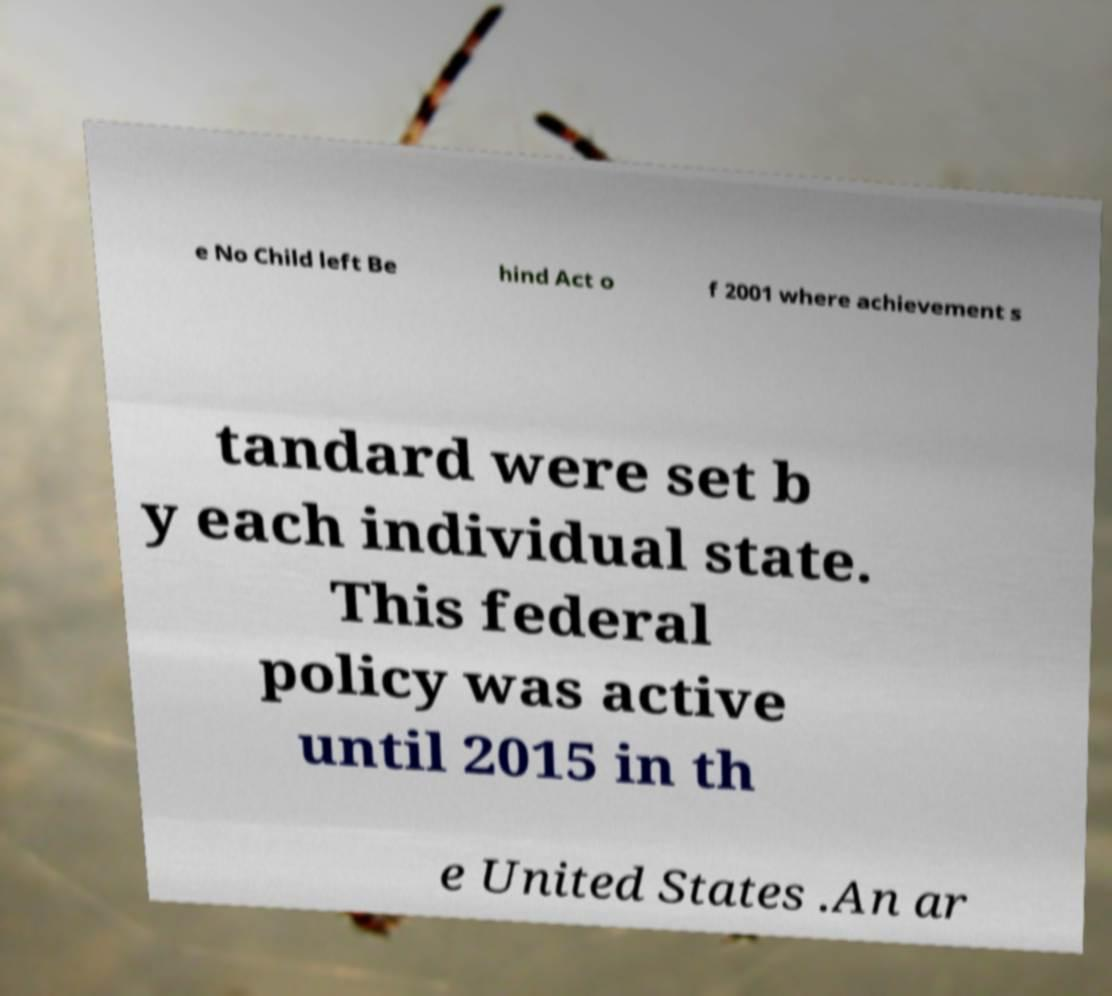Can you read and provide the text displayed in the image?This photo seems to have some interesting text. Can you extract and type it out for me? e No Child left Be hind Act o f 2001 where achievement s tandard were set b y each individual state. This federal policy was active until 2015 in th e United States .An ar 